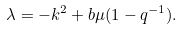Convert formula to latex. <formula><loc_0><loc_0><loc_500><loc_500>\lambda = - k ^ { 2 } + b \mu ( 1 - q ^ { - 1 } ) .</formula> 